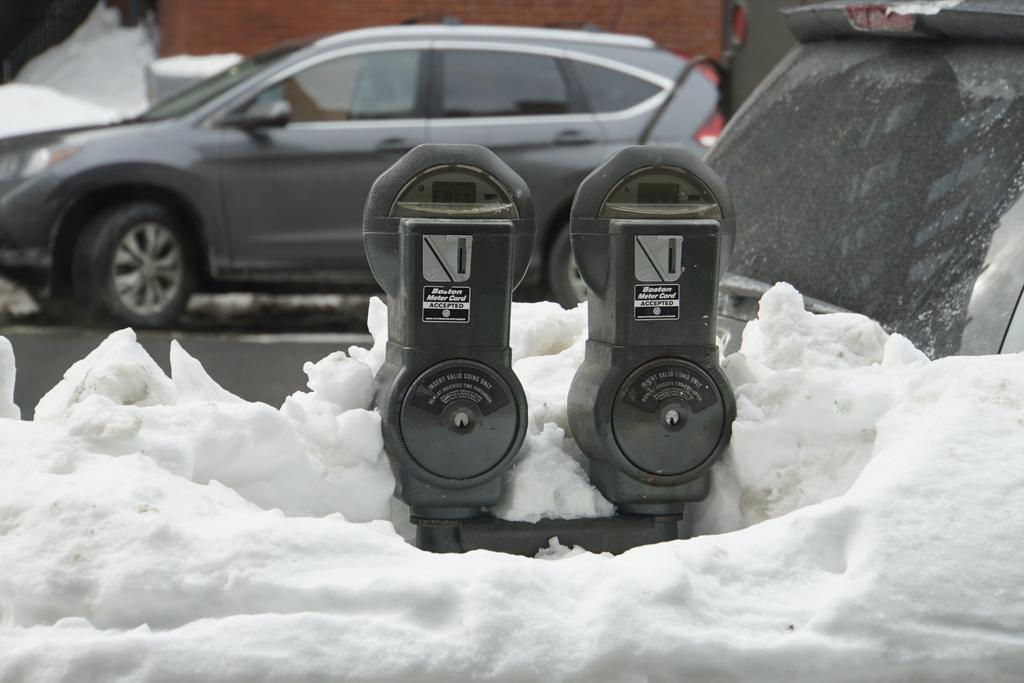<image>
Create a compact narrative representing the image presented. Thermometer in the snow that says "Boston Meter Card Accepted". 